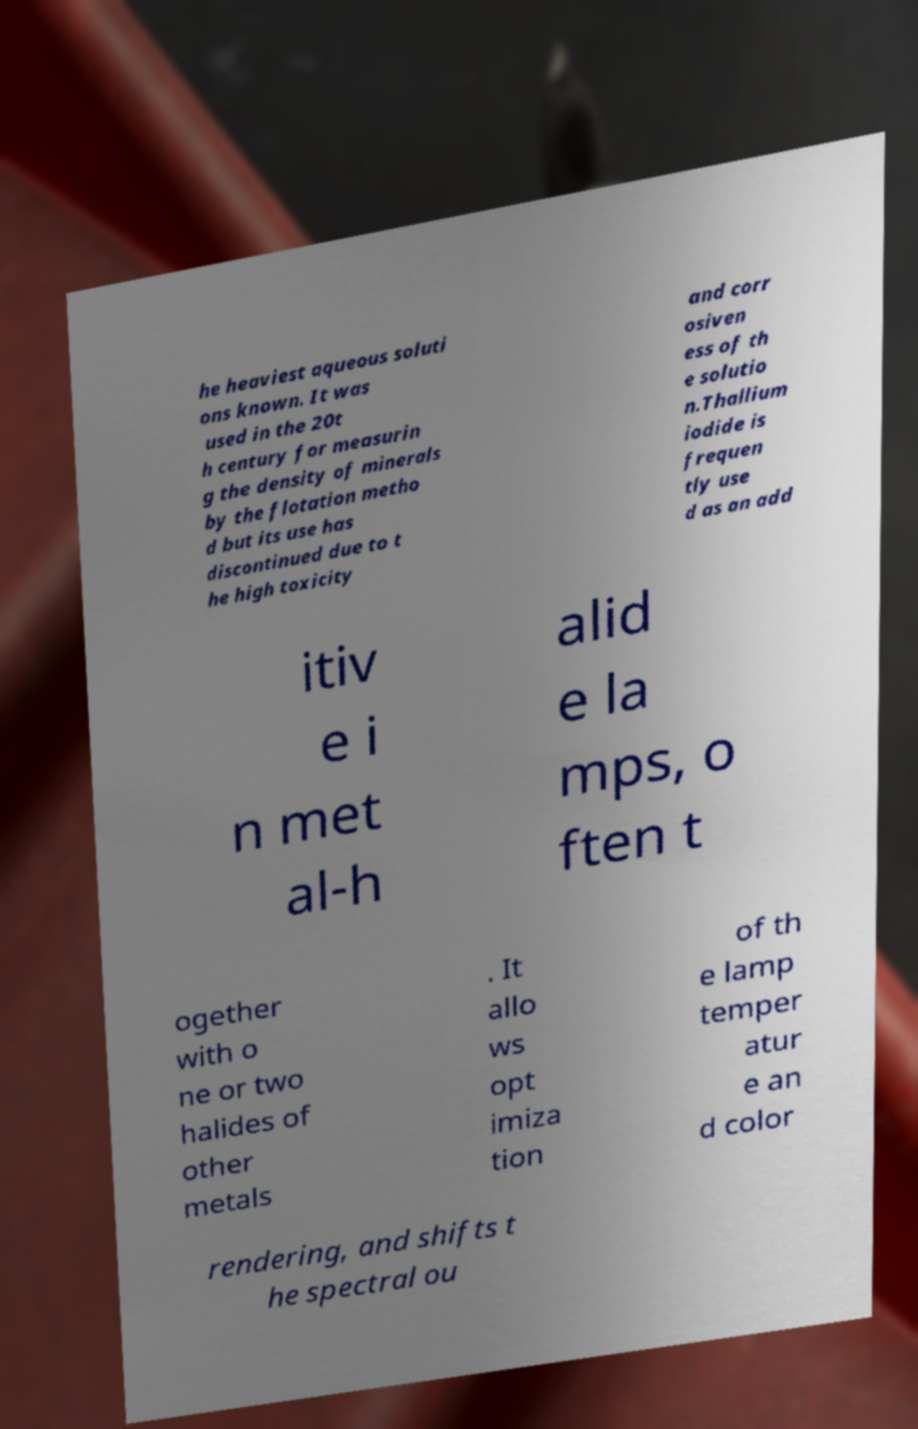Please read and relay the text visible in this image. What does it say? he heaviest aqueous soluti ons known. It was used in the 20t h century for measurin g the density of minerals by the flotation metho d but its use has discontinued due to t he high toxicity and corr osiven ess of th e solutio n.Thallium iodide is frequen tly use d as an add itiv e i n met al-h alid e la mps, o ften t ogether with o ne or two halides of other metals . It allo ws opt imiza tion of th e lamp temper atur e an d color rendering, and shifts t he spectral ou 